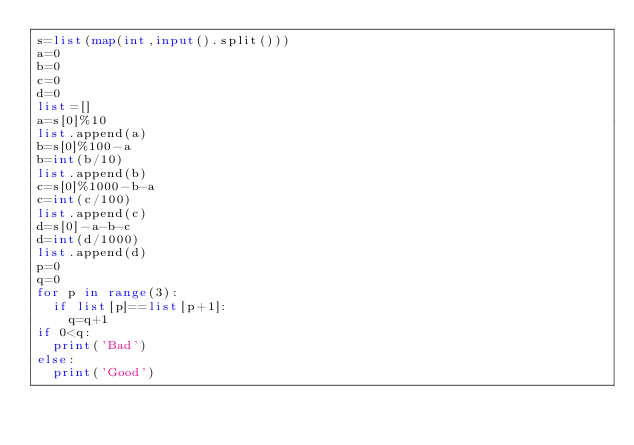<code> <loc_0><loc_0><loc_500><loc_500><_Python_>s=list(map(int,input().split()))
a=0
b=0
c=0
d=0
list=[]
a=s[0]%10
list.append(a)
b=s[0]%100-a
b=int(b/10)
list.append(b)
c=s[0]%1000-b-a
c=int(c/100)
list.append(c)
d=s[0]-a-b-c
d=int(d/1000)
list.append(d)
p=0
q=0
for p in range(3):
  if list[p]==list[p+1]:
    q=q+1
if 0<q:
  print('Bad')
else:
  print('Good')</code> 